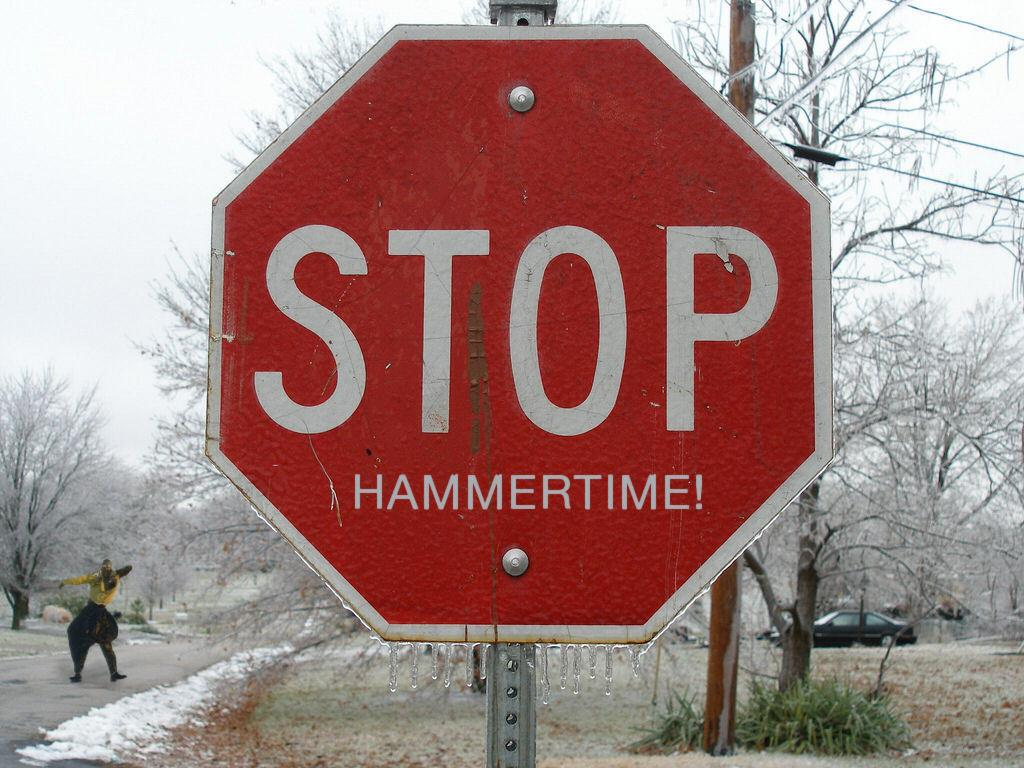Provide a one-sentence caption for the provided image. A red stop sign with the words "Hammertime!" below it. 